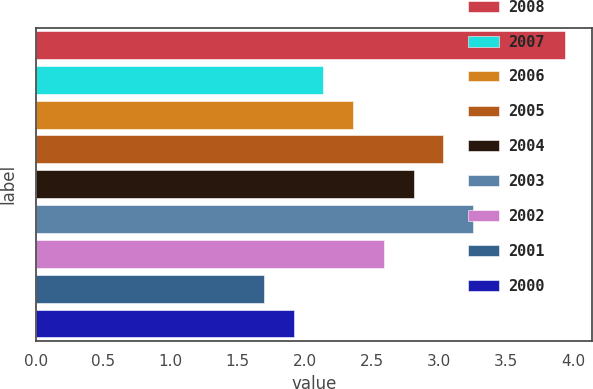<chart> <loc_0><loc_0><loc_500><loc_500><bar_chart><fcel>2008<fcel>2007<fcel>2006<fcel>2005<fcel>2004<fcel>2003<fcel>2002<fcel>2001<fcel>2000<nl><fcel>3.94<fcel>2.14<fcel>2.36<fcel>3.03<fcel>2.81<fcel>3.25<fcel>2.59<fcel>1.7<fcel>1.92<nl></chart> 